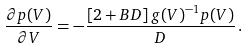Convert formula to latex. <formula><loc_0><loc_0><loc_500><loc_500>\frac { \partial p ( V ) } { \partial V } = - \frac { \left [ 2 + B D \right ] g ( V ) ^ { - 1 } p ( V ) } { D } \, .</formula> 